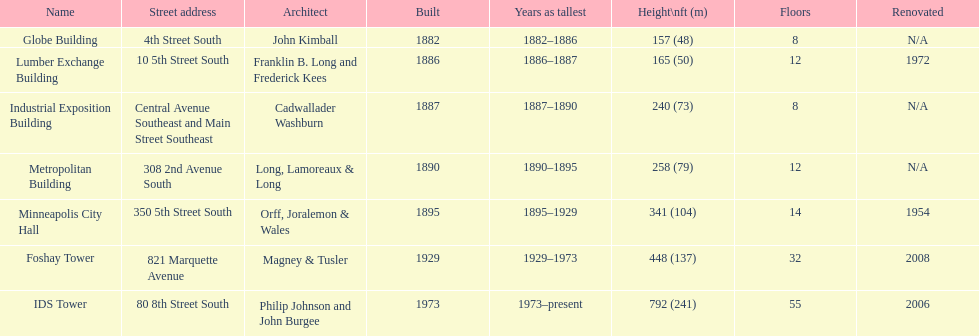What was the first building named as the tallest? Globe Building. 